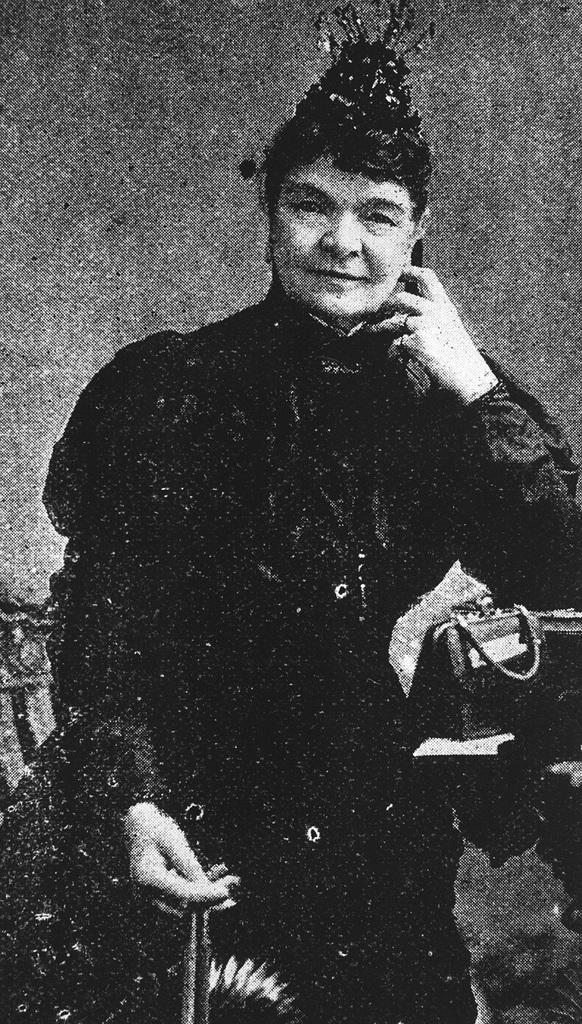What type of picture is in the image? There is a black and white picture of a woman in the image. What is the woman doing in the picture? The woman is holding an object in her hand. What can be seen on the right side of the image? There is a bag placed on the right side of the image. How many boys are visible in the image? There are no boys visible in the image; it features a picture of a woman holding an object. What type of insect can be seen crawling on the woman's shoulder in the image? There is no insect visible on the woman's shoulder in the image. 